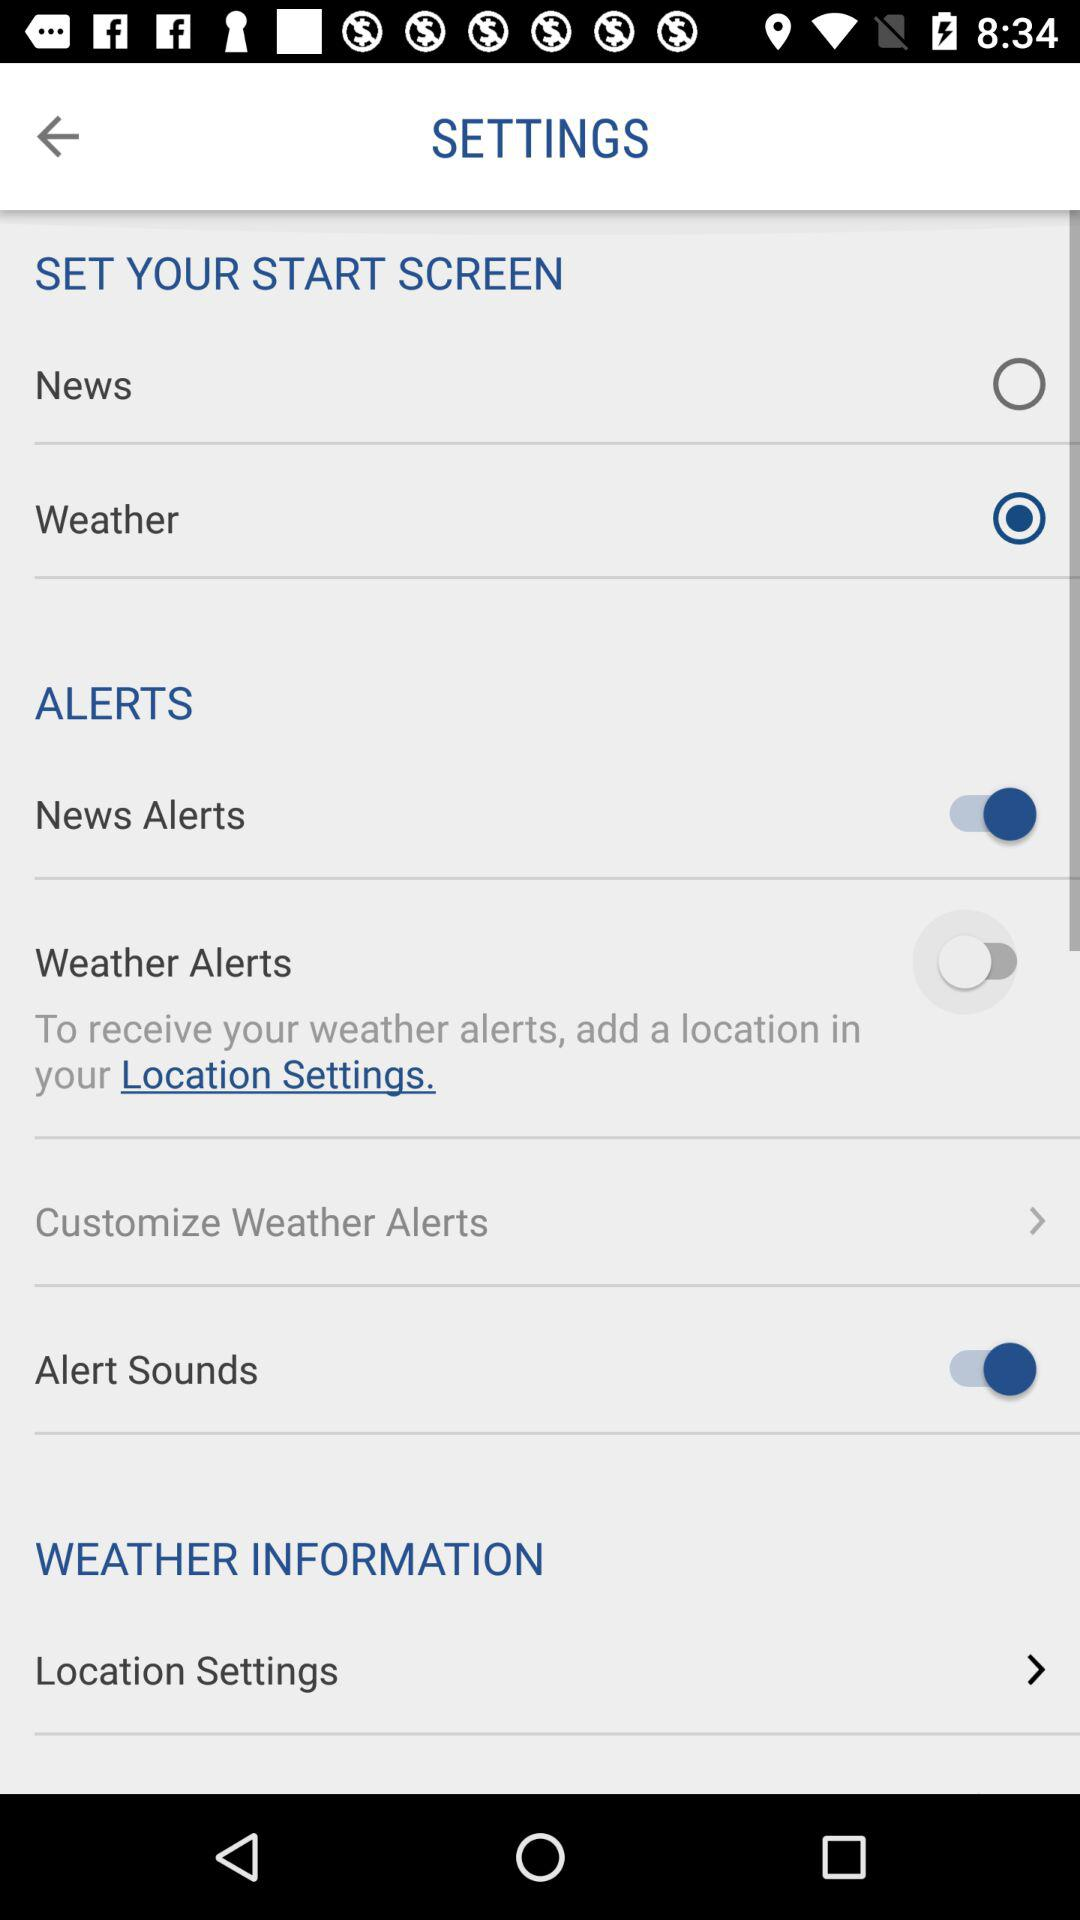What is Customized Weather Alerts?
When the provided information is insufficient, respond with <no answer>. <no answer> 